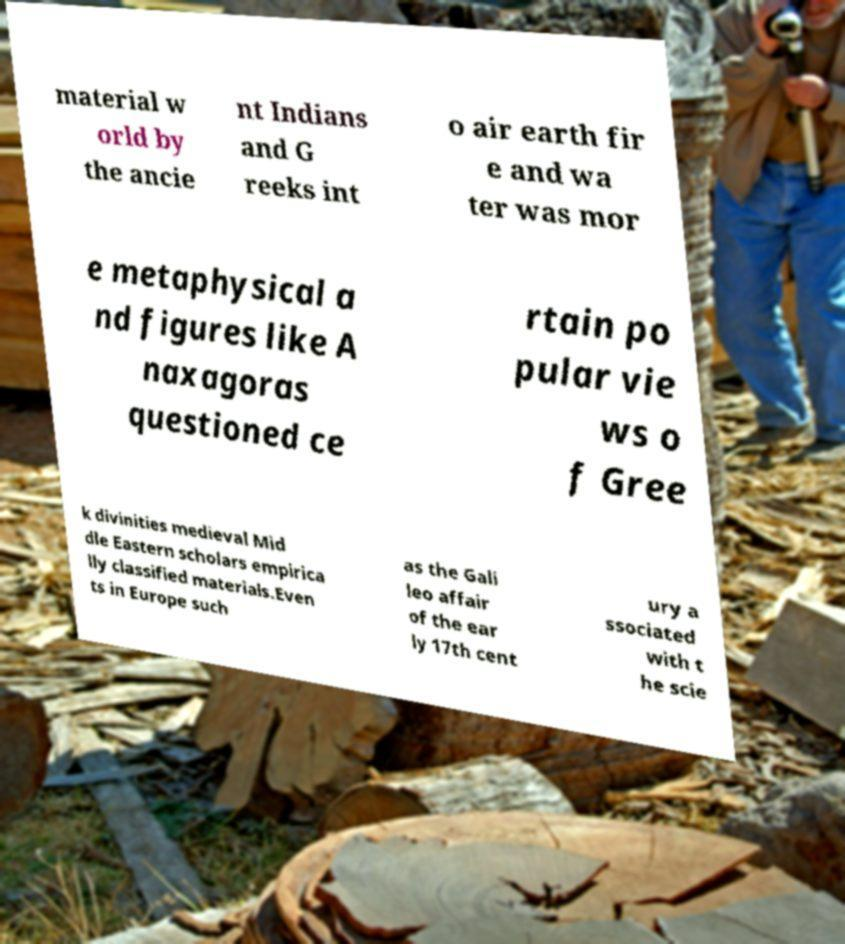For documentation purposes, I need the text within this image transcribed. Could you provide that? material w orld by the ancie nt Indians and G reeks int o air earth fir e and wa ter was mor e metaphysical a nd figures like A naxagoras questioned ce rtain po pular vie ws o f Gree k divinities medieval Mid dle Eastern scholars empirica lly classified materials.Even ts in Europe such as the Gali leo affair of the ear ly 17th cent ury a ssociated with t he scie 